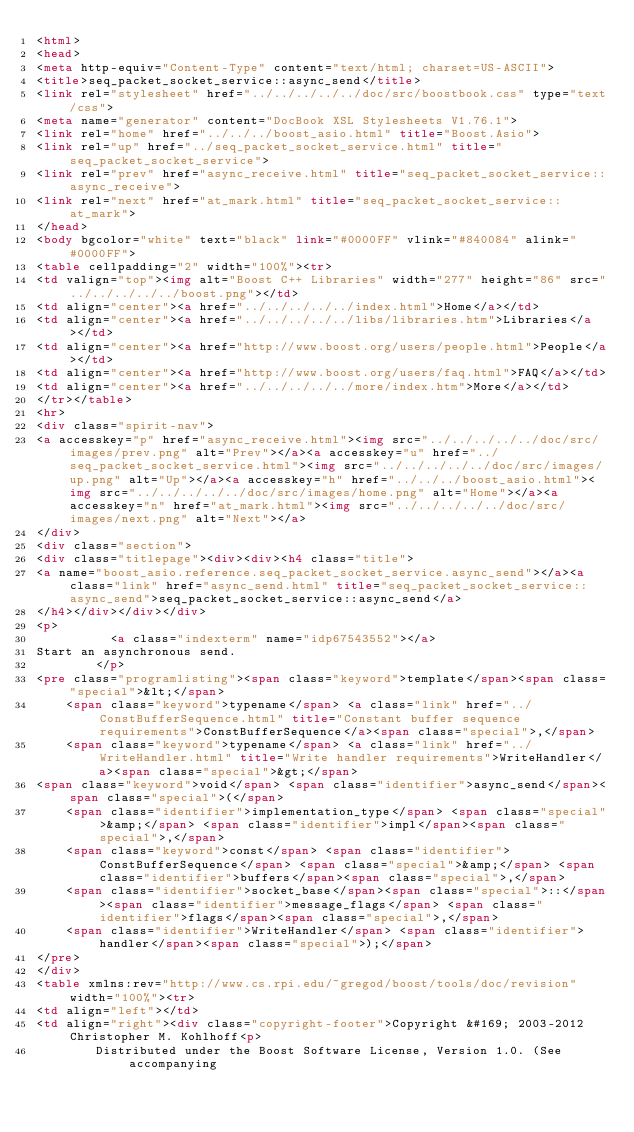<code> <loc_0><loc_0><loc_500><loc_500><_HTML_><html>
<head>
<meta http-equiv="Content-Type" content="text/html; charset=US-ASCII">
<title>seq_packet_socket_service::async_send</title>
<link rel="stylesheet" href="../../../../../doc/src/boostbook.css" type="text/css">
<meta name="generator" content="DocBook XSL Stylesheets V1.76.1">
<link rel="home" href="../../../boost_asio.html" title="Boost.Asio">
<link rel="up" href="../seq_packet_socket_service.html" title="seq_packet_socket_service">
<link rel="prev" href="async_receive.html" title="seq_packet_socket_service::async_receive">
<link rel="next" href="at_mark.html" title="seq_packet_socket_service::at_mark">
</head>
<body bgcolor="white" text="black" link="#0000FF" vlink="#840084" alink="#0000FF">
<table cellpadding="2" width="100%"><tr>
<td valign="top"><img alt="Boost C++ Libraries" width="277" height="86" src="../../../../../boost.png"></td>
<td align="center"><a href="../../../../../index.html">Home</a></td>
<td align="center"><a href="../../../../../libs/libraries.htm">Libraries</a></td>
<td align="center"><a href="http://www.boost.org/users/people.html">People</a></td>
<td align="center"><a href="http://www.boost.org/users/faq.html">FAQ</a></td>
<td align="center"><a href="../../../../../more/index.htm">More</a></td>
</tr></table>
<hr>
<div class="spirit-nav">
<a accesskey="p" href="async_receive.html"><img src="../../../../../doc/src/images/prev.png" alt="Prev"></a><a accesskey="u" href="../seq_packet_socket_service.html"><img src="../../../../../doc/src/images/up.png" alt="Up"></a><a accesskey="h" href="../../../boost_asio.html"><img src="../../../../../doc/src/images/home.png" alt="Home"></a><a accesskey="n" href="at_mark.html"><img src="../../../../../doc/src/images/next.png" alt="Next"></a>
</div>
<div class="section">
<div class="titlepage"><div><div><h4 class="title">
<a name="boost_asio.reference.seq_packet_socket_service.async_send"></a><a class="link" href="async_send.html" title="seq_packet_socket_service::async_send">seq_packet_socket_service::async_send</a>
</h4></div></div></div>
<p>
          <a class="indexterm" name="idp67543552"></a> 
Start an asynchronous send.
        </p>
<pre class="programlisting"><span class="keyword">template</span><span class="special">&lt;</span>
    <span class="keyword">typename</span> <a class="link" href="../ConstBufferSequence.html" title="Constant buffer sequence requirements">ConstBufferSequence</a><span class="special">,</span>
    <span class="keyword">typename</span> <a class="link" href="../WriteHandler.html" title="Write handler requirements">WriteHandler</a><span class="special">&gt;</span>
<span class="keyword">void</span> <span class="identifier">async_send</span><span class="special">(</span>
    <span class="identifier">implementation_type</span> <span class="special">&amp;</span> <span class="identifier">impl</span><span class="special">,</span>
    <span class="keyword">const</span> <span class="identifier">ConstBufferSequence</span> <span class="special">&amp;</span> <span class="identifier">buffers</span><span class="special">,</span>
    <span class="identifier">socket_base</span><span class="special">::</span><span class="identifier">message_flags</span> <span class="identifier">flags</span><span class="special">,</span>
    <span class="identifier">WriteHandler</span> <span class="identifier">handler</span><span class="special">);</span>
</pre>
</div>
<table xmlns:rev="http://www.cs.rpi.edu/~gregod/boost/tools/doc/revision" width="100%"><tr>
<td align="left"></td>
<td align="right"><div class="copyright-footer">Copyright &#169; 2003-2012 Christopher M. Kohlhoff<p>
        Distributed under the Boost Software License, Version 1.0. (See accompanying</code> 